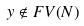<formula> <loc_0><loc_0><loc_500><loc_500>y \notin F V ( N )</formula> 